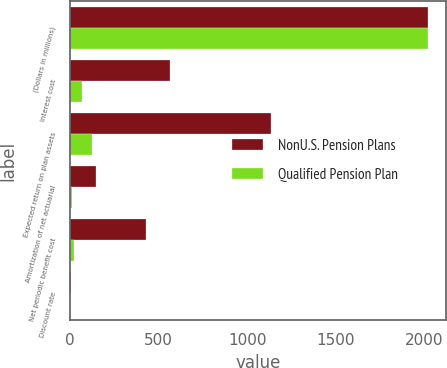Convert chart. <chart><loc_0><loc_0><loc_500><loc_500><stacked_bar_chart><ecel><fcel>(Dollars in millions)<fcel>Interest cost<fcel>Expected return on plan assets<fcel>Amortization of net actuarial<fcel>Net periodic benefit cost<fcel>Discount rate<nl><fcel>NonU.S. Pension Plans<fcel>2018<fcel>563<fcel>1136<fcel>147<fcel>426<fcel>3.68<nl><fcel>Qualified Pension Plan<fcel>2018<fcel>65<fcel>126<fcel>10<fcel>20<fcel>2.39<nl></chart> 